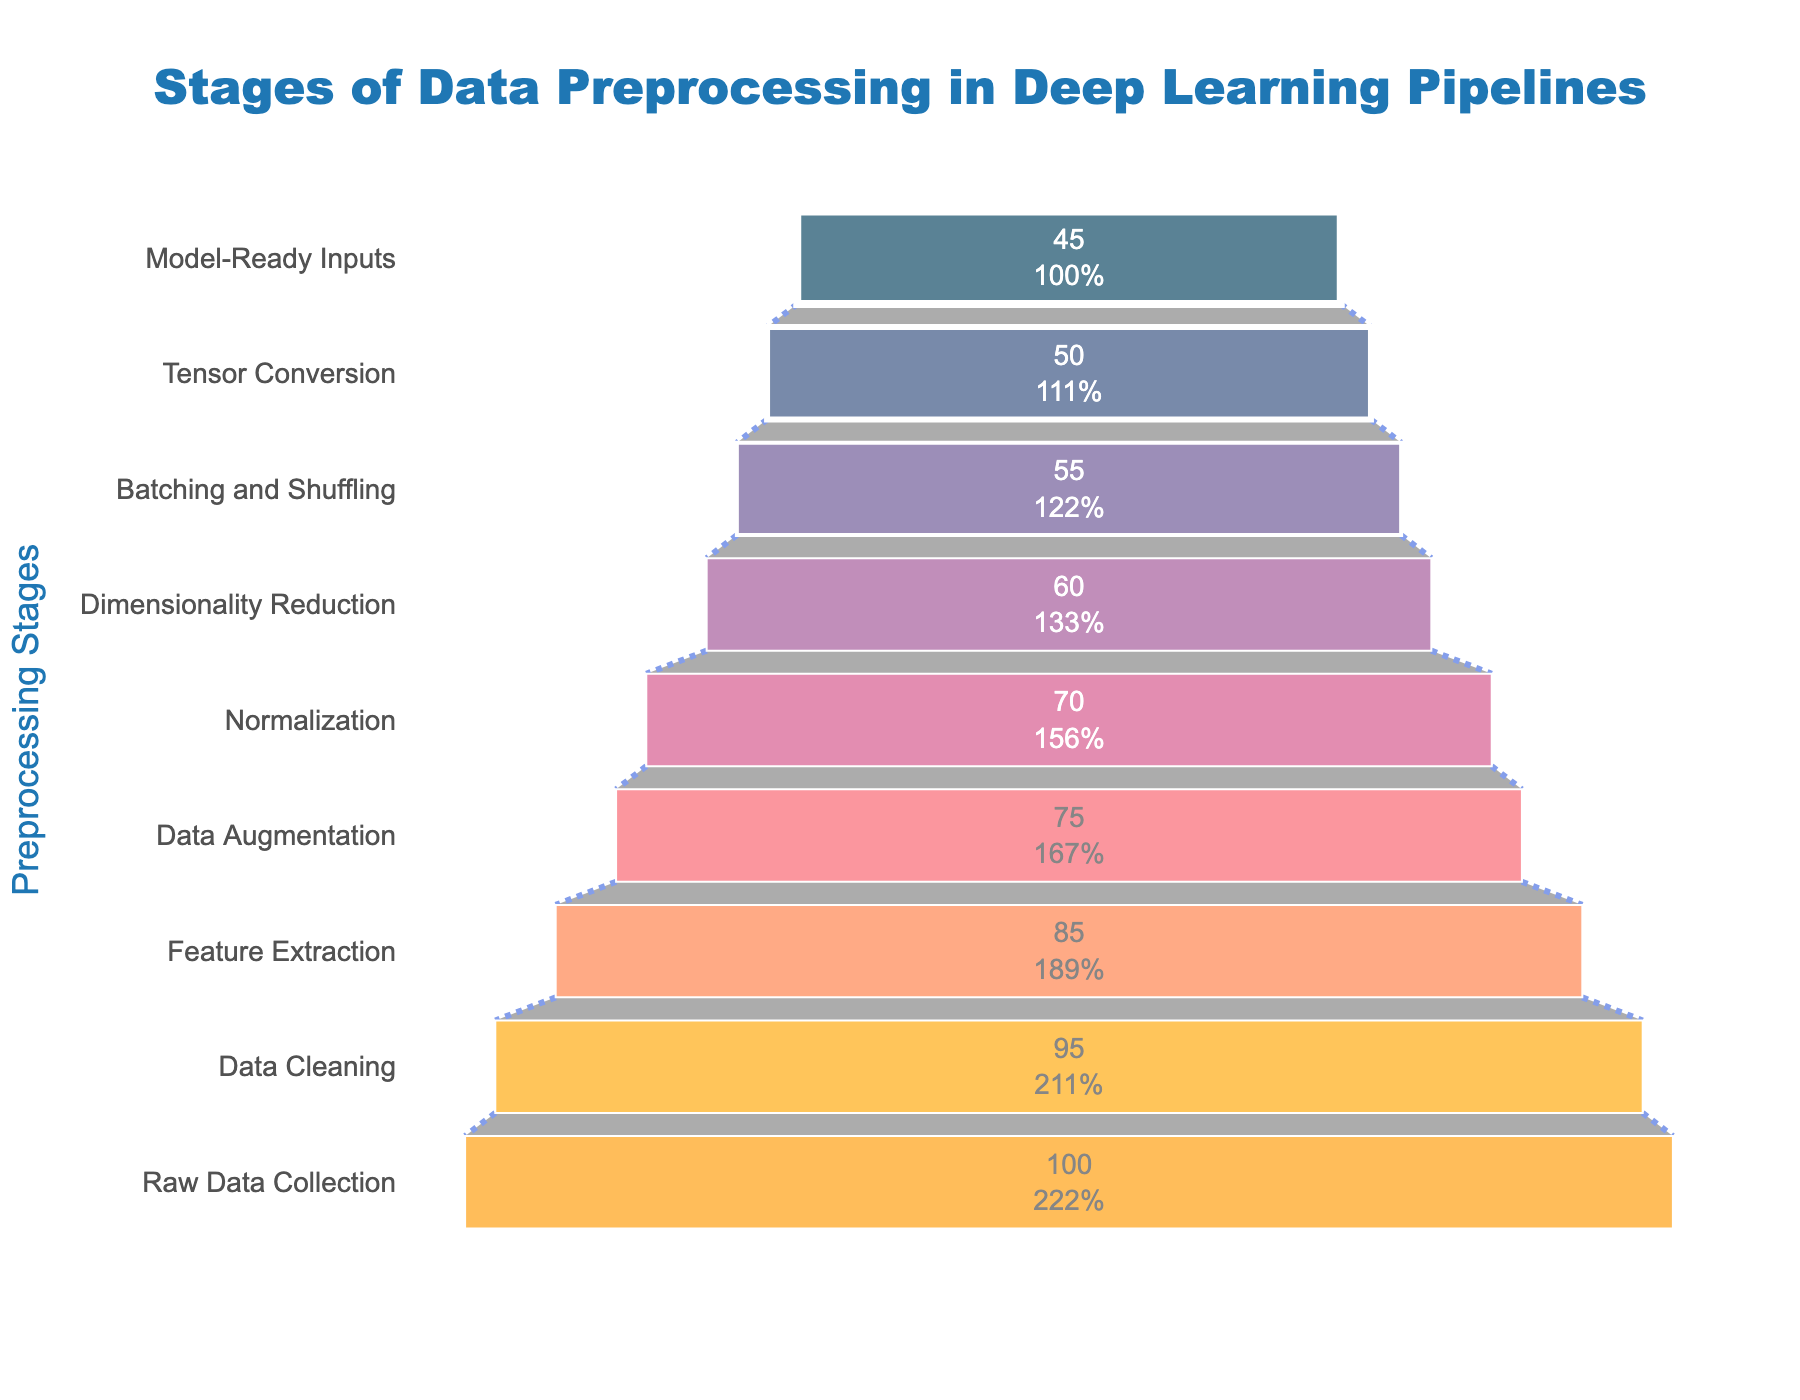What's the title of the funnel chart? The title of the chart is usually displayed prominently at the top of the figure. In this case, it reads "Stages of Data Preprocessing in Deep Learning Pipelines".
Answer: Stages of Data Preprocessing in Deep Learning Pipelines How many stages are there in the funnel chart? By counting the number of distinct stages listed on the y-axis of the funnel chart, we can determine the total number of stages.
Answer: 9 What is the percentage of data remaining after Data Augmentation? By locating the "Data Augmentation" stage on the y-axis and referring to the x-axis value directly next to it, we can determine the percentage.
Answer: 75% Which stage has the greatest drop in data percentage compared to the previous stage? To find this, calculate the differences between the percentages of consecutive stages and identify the stage with the largest drop. The largest decrease appears between "Dimensionality Reduction" and "Batching and Shuffling".
Answer: Dimensionality Reduction to Batching and Shuffling What percentage of data is ready for the model at the end of the preprocessing pipeline? Referring to the final stage "Model-Ready Inputs" and reading the corresponding value on the x-axis, we find the percentage of data ready for the model.
Answer: 45% How much data is lost from Raw Data Collection to Feature Extraction? To find this, subtract the percentage of data remaining at the "Feature Extraction" stage from the percentage at the "Raw Data Collection" stage: 100 - 85.
Answer: 15% Which two stages have the smallest percentage drop between them? Calculate the differences between consecutive stages and identify the two stages with the smallest percentage drop. The smallest drop is between "Normalization" and "Dimensionality Reduction": 70 - 60 = 10.
Answer: Normalization to Dimensionality Reduction What is the combined percentage drop from Raw Data Collection to Normalization? Sum the individual drops from stage to stage up to and including "Normalization". The drops are: (100 - 95) + (95 - 85) + (85 - 75) + (75 - 70) = 5 + 10 + 10 + 5.
Answer: 30% How many stages have a percentage of data remaining below 60%? By referring to the x-axis values, we count the stages where the percentage is below 60. These stages are "Batching and Shuffling," "Tensor Conversion," and "Model-Ready Inputs".
Answer: 3 What percentage of data is lost during the Data Cleaning stage? To determine the loss, subtract the percentage remaining after Data Cleaning from the percentage at the Raw Data Collection stage: 100 - 95.
Answer: 5% 